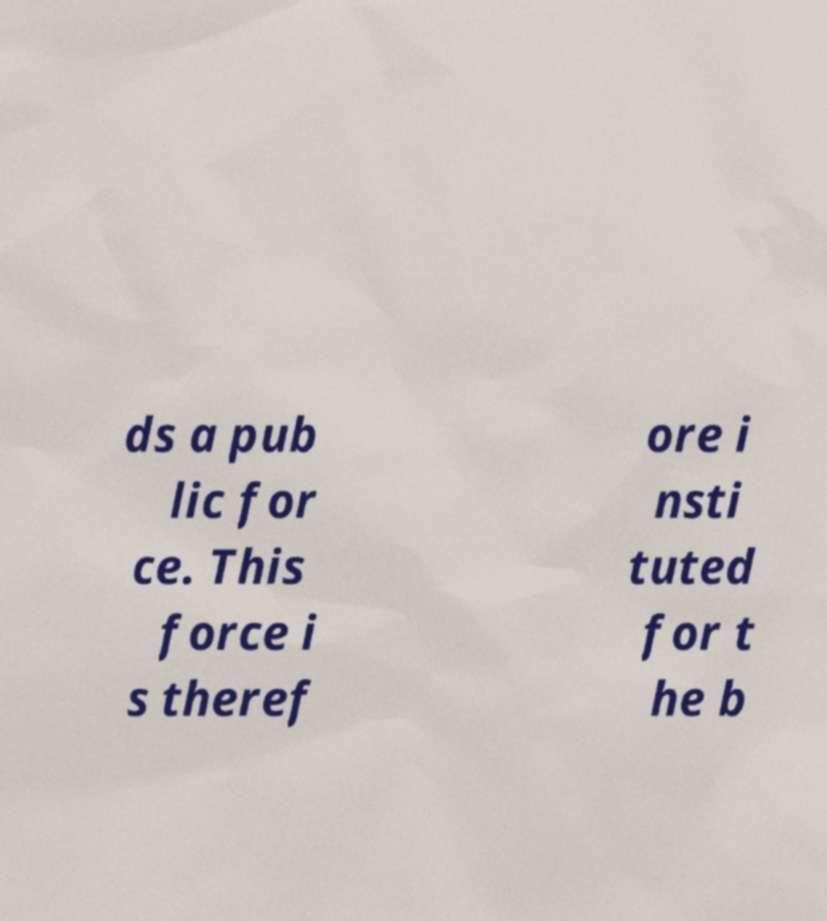There's text embedded in this image that I need extracted. Can you transcribe it verbatim? ds a pub lic for ce. This force i s theref ore i nsti tuted for t he b 